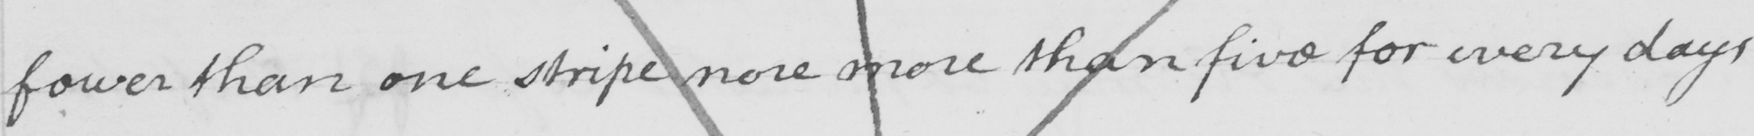Please provide the text content of this handwritten line. fewer than one stripe nore more than five for every days 